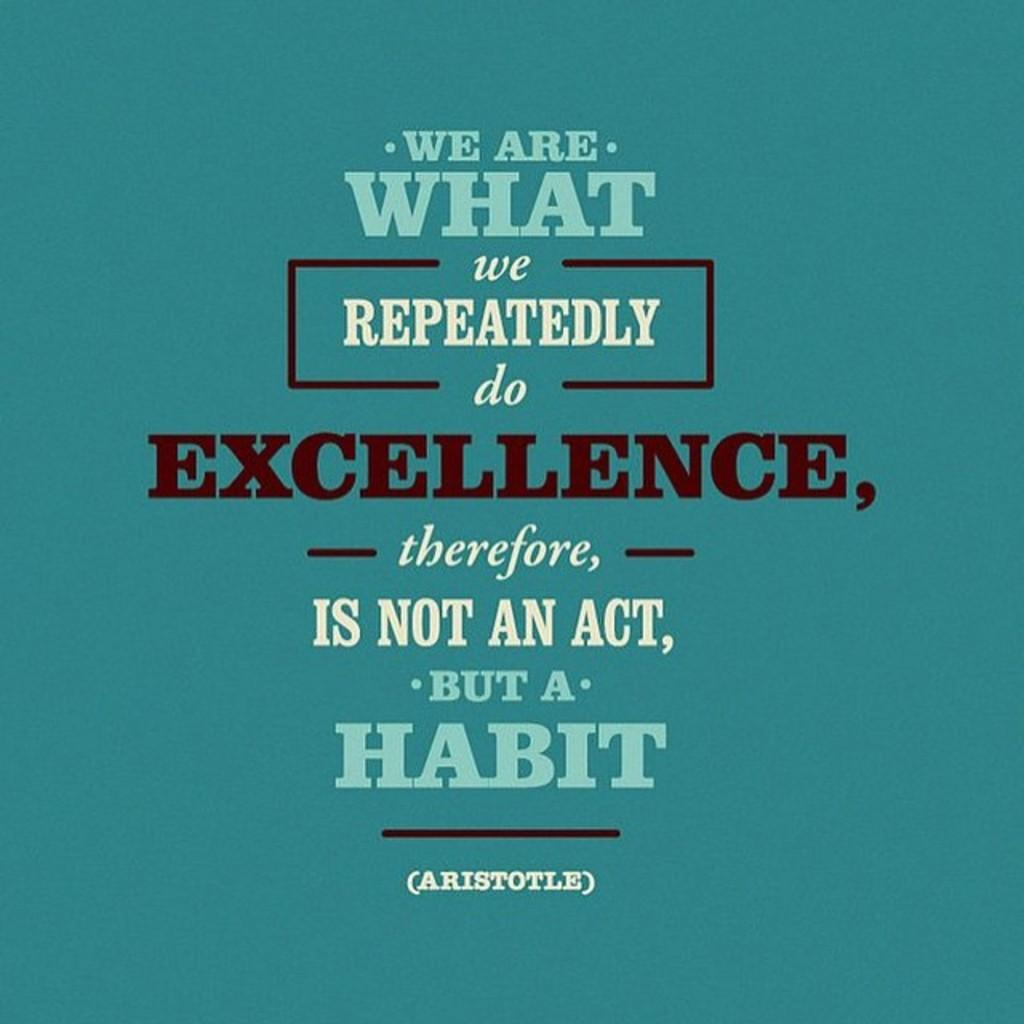<image>
Create a compact narrative representing the image presented. Written in bold letters, on an aqua back ground is a famous quote by Aristotle regarding a person's habit's. 